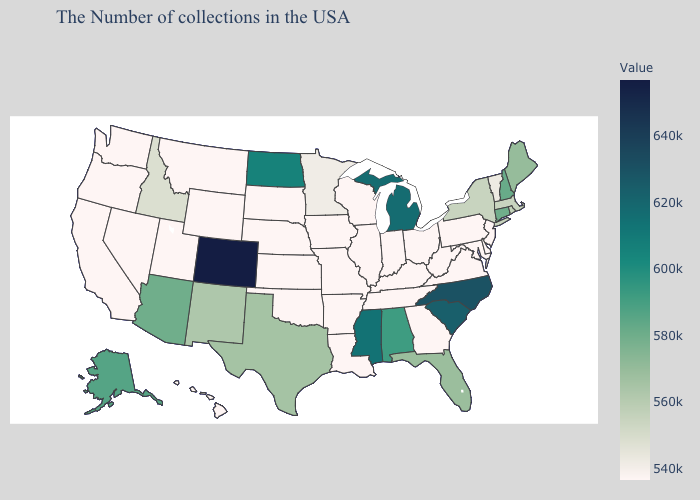Which states have the lowest value in the USA?
Keep it brief. New Jersey, Delaware, Maryland, Pennsylvania, Virginia, West Virginia, Ohio, Georgia, Kentucky, Indiana, Tennessee, Wisconsin, Illinois, Louisiana, Missouri, Arkansas, Iowa, Kansas, Nebraska, Oklahoma, South Dakota, Wyoming, Utah, Montana, Nevada, California, Washington, Oregon, Hawaii. Does Mississippi have the highest value in the USA?
Answer briefly. No. Among the states that border Florida , which have the lowest value?
Give a very brief answer. Georgia. Which states have the lowest value in the USA?
Keep it brief. New Jersey, Delaware, Maryland, Pennsylvania, Virginia, West Virginia, Ohio, Georgia, Kentucky, Indiana, Tennessee, Wisconsin, Illinois, Louisiana, Missouri, Arkansas, Iowa, Kansas, Nebraska, Oklahoma, South Dakota, Wyoming, Utah, Montana, Nevada, California, Washington, Oregon, Hawaii. Among the states that border Louisiana , does Mississippi have the lowest value?
Concise answer only. No. 